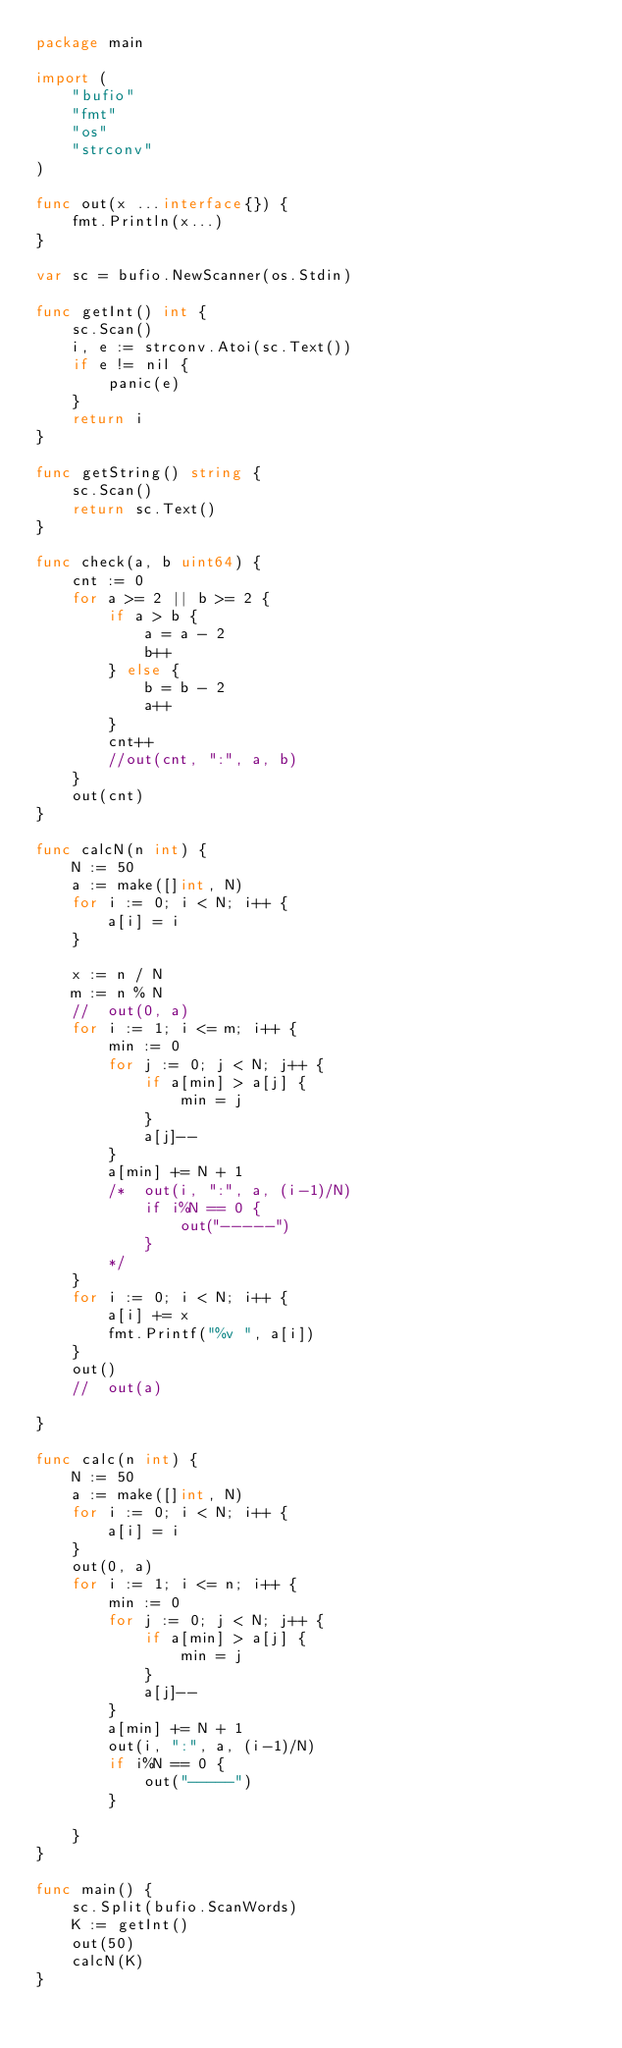<code> <loc_0><loc_0><loc_500><loc_500><_Go_>package main

import (
	"bufio"
	"fmt"
	"os"
	"strconv"
)

func out(x ...interface{}) {
	fmt.Println(x...)
}

var sc = bufio.NewScanner(os.Stdin)

func getInt() int {
	sc.Scan()
	i, e := strconv.Atoi(sc.Text())
	if e != nil {
		panic(e)
	}
	return i
}

func getString() string {
	sc.Scan()
	return sc.Text()
}

func check(a, b uint64) {
	cnt := 0
	for a >= 2 || b >= 2 {
		if a > b {
			a = a - 2
			b++
		} else {
			b = b - 2
			a++
		}
		cnt++
		//out(cnt, ":", a, b)
	}
	out(cnt)
}

func calcN(n int) {
	N := 50
	a := make([]int, N)
	for i := 0; i < N; i++ {
		a[i] = i
	}

	x := n / N
	m := n % N
	//	out(0, a)
	for i := 1; i <= m; i++ {
		min := 0
		for j := 0; j < N; j++ {
			if a[min] > a[j] {
				min = j
			}
			a[j]--
		}
		a[min] += N + 1
		/*	out(i, ":", a, (i-1)/N)
			if i%N == 0 {
				out("-----")
			}
		*/
	}
	for i := 0; i < N; i++ {
		a[i] += x
		fmt.Printf("%v ", a[i])
	}
	out()
	//	out(a)

}

func calc(n int) {
	N := 50
	a := make([]int, N)
	for i := 0; i < N; i++ {
		a[i] = i
	}
	out(0, a)
	for i := 1; i <= n; i++ {
		min := 0
		for j := 0; j < N; j++ {
			if a[min] > a[j] {
				min = j
			}
			a[j]--
		}
		a[min] += N + 1
		out(i, ":", a, (i-1)/N)
		if i%N == 0 {
			out("-----")
		}

	}
}

func main() {
	sc.Split(bufio.ScanWords)
	K := getInt()
	out(50)
	calcN(K)
}
</code> 